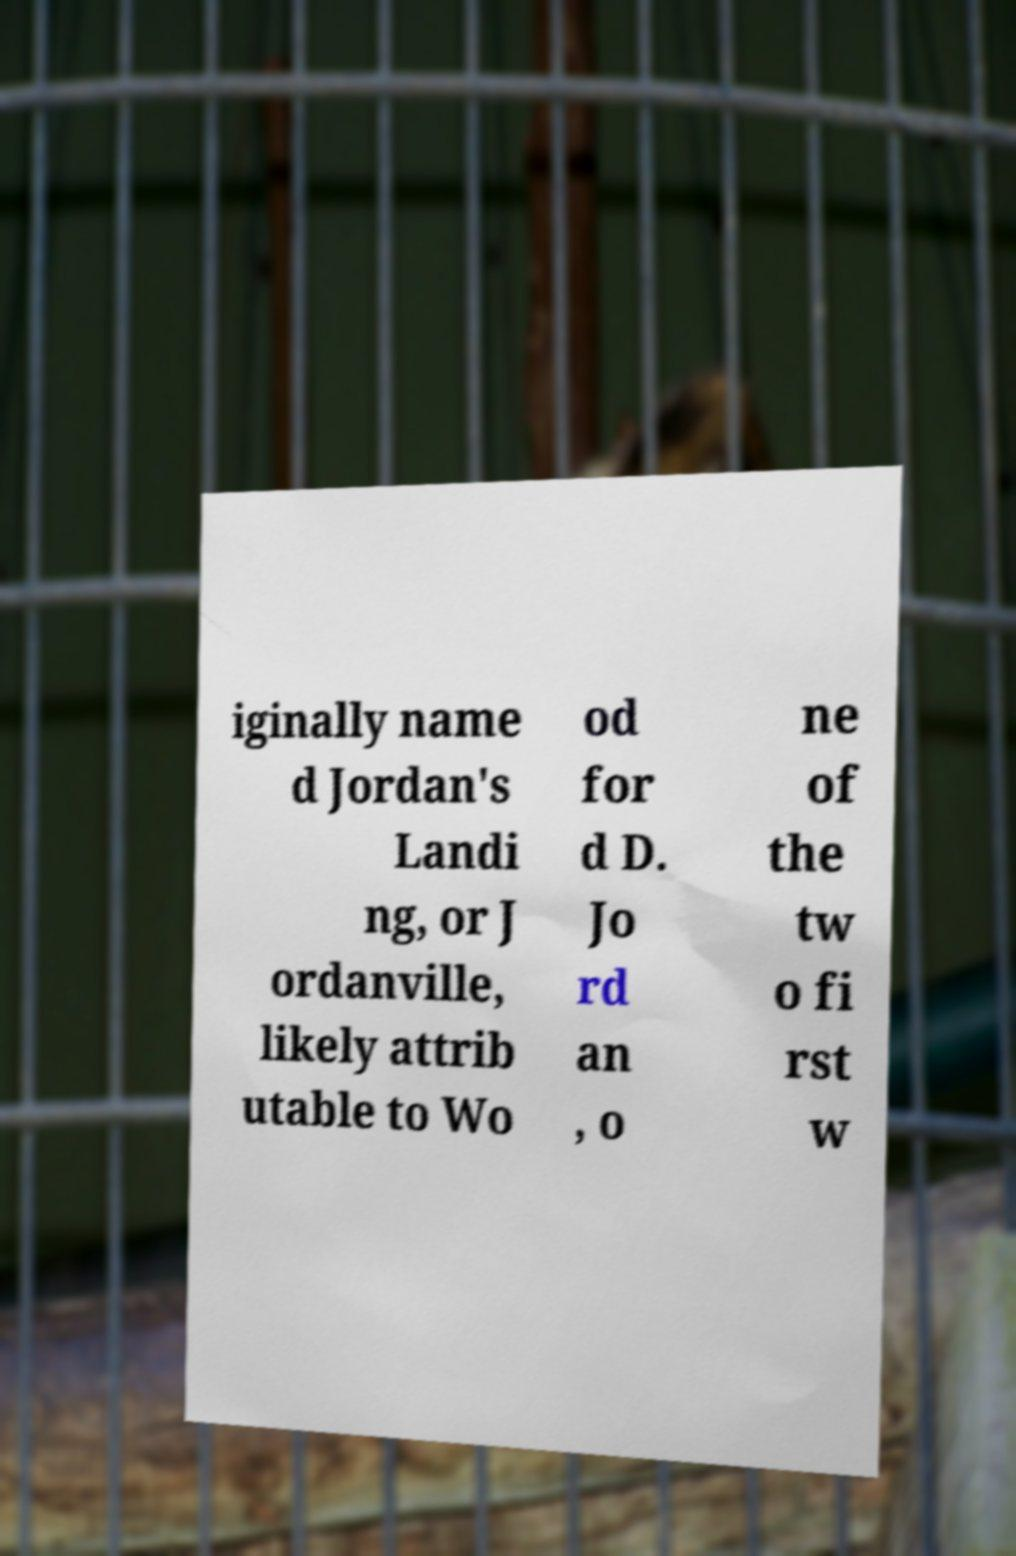Please read and relay the text visible in this image. What does it say? iginally name d Jordan's Landi ng, or J ordanville, likely attrib utable to Wo od for d D. Jo rd an , o ne of the tw o fi rst w 